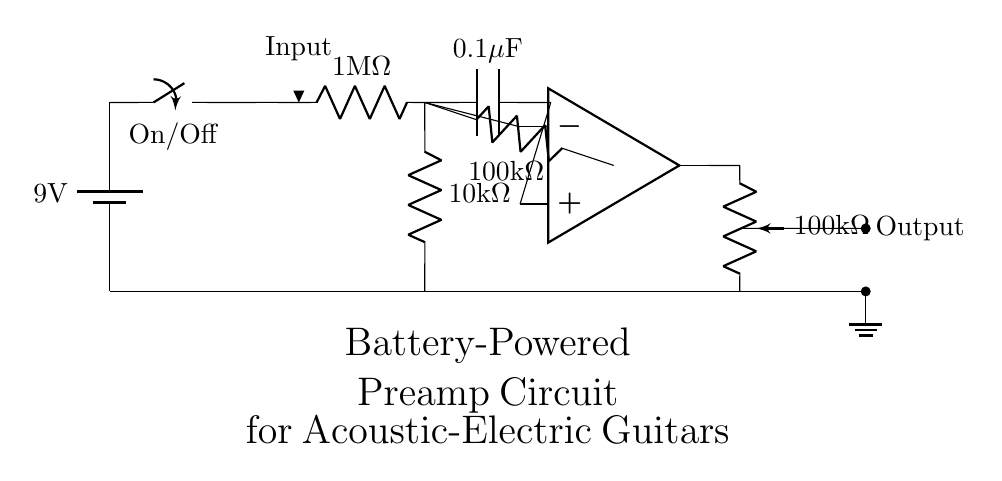What is the voltage of this circuit? The voltage is 9 volts, which is the value indicated next to the battery symbol in the circuit diagram.
Answer: 9 volts What type of circuit component is used for audio input? The audio input is connected via an input jack, represented by an arrow in the diagram pointing downward, indicating where the acoustic-electric guitar connects.
Answer: Input jack How many resistors are present in this circuit? There are three resistors in the circuit: one at one megaohm, one at ten kiloohms, and one at one hundred kiloohms for feedback.
Answer: Three What is the purpose of the capacitor in this circuit? The capacitor, with a value of 0.1 microfarads, is used to block DC voltage while allowing AC signals (like audio) to pass through, essentially coupling the signals.
Answer: Coupling What is the configuration of the operational amplifier in the circuit? The operational amplifier is configured for non-inverting amplification since the input signal connects to the non-inverting input (+), while the feedback connects from the output to the inverting input (-).
Answer: Non-inverting What is the resistance value of the volume potentiometer? The volume potentiometer has a resistance value of one hundred kiloohms, which is critical for controlling the output level of the audio signal.
Answer: One hundred kiloohms 